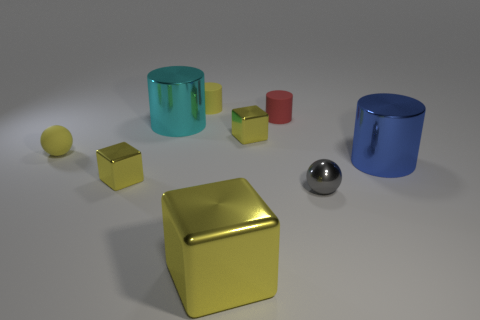How many other things are there of the same material as the small yellow cylinder?
Give a very brief answer. 2. Is the shape of the blue thing the same as the cyan metallic object that is behind the shiny sphere?
Provide a succinct answer. Yes. Are there any big blue objects behind the cyan metallic object?
Provide a short and direct response. No. What material is the large object that is the same color as the small rubber ball?
Offer a very short reply. Metal. There is a gray metallic sphere; is its size the same as the block that is behind the blue metallic cylinder?
Offer a terse response. Yes. Is there a rubber cylinder that has the same color as the matte sphere?
Offer a very short reply. Yes. Is there a tiny yellow object that has the same shape as the small gray thing?
Give a very brief answer. Yes. What is the shape of the thing that is both behind the yellow rubber sphere and to the left of the yellow cylinder?
Ensure brevity in your answer.  Cylinder. What number of gray balls have the same material as the yellow cylinder?
Give a very brief answer. 0. Are there fewer gray spheres that are behind the small red rubber thing than blue shiny balls?
Provide a succinct answer. No. 